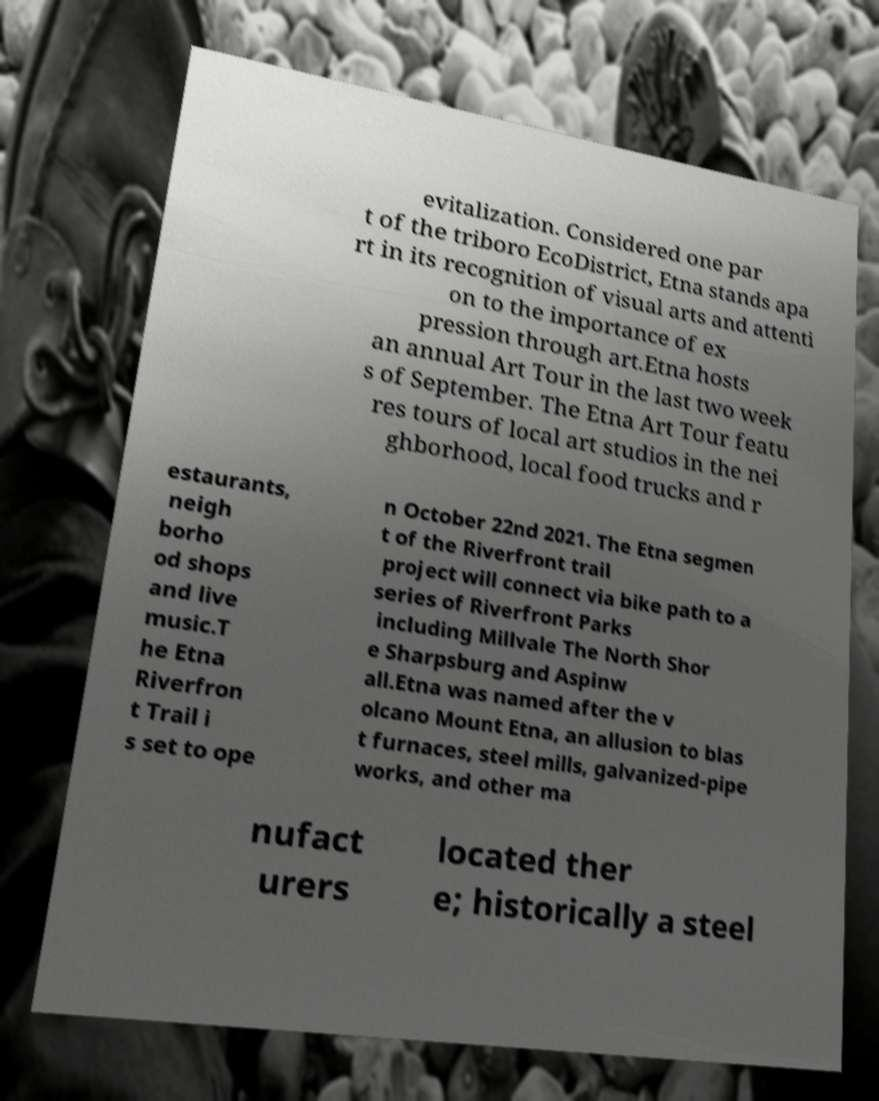What messages or text are displayed in this image? I need them in a readable, typed format. evitalization. Considered one par t of the triboro EcoDistrict, Etna stands apa rt in its recognition of visual arts and attenti on to the importance of ex pression through art.Etna hosts an annual Art Tour in the last two week s of September. The Etna Art Tour featu res tours of local art studios in the nei ghborhood, local food trucks and r estaurants, neigh borho od shops and live music.T he Etna Riverfron t Trail i s set to ope n October 22nd 2021. The Etna segmen t of the Riverfront trail project will connect via bike path to a series of Riverfront Parks including Millvale The North Shor e Sharpsburg and Aspinw all.Etna was named after the v olcano Mount Etna, an allusion to blas t furnaces, steel mills, galvanized-pipe works, and other ma nufact urers located ther e; historically a steel 